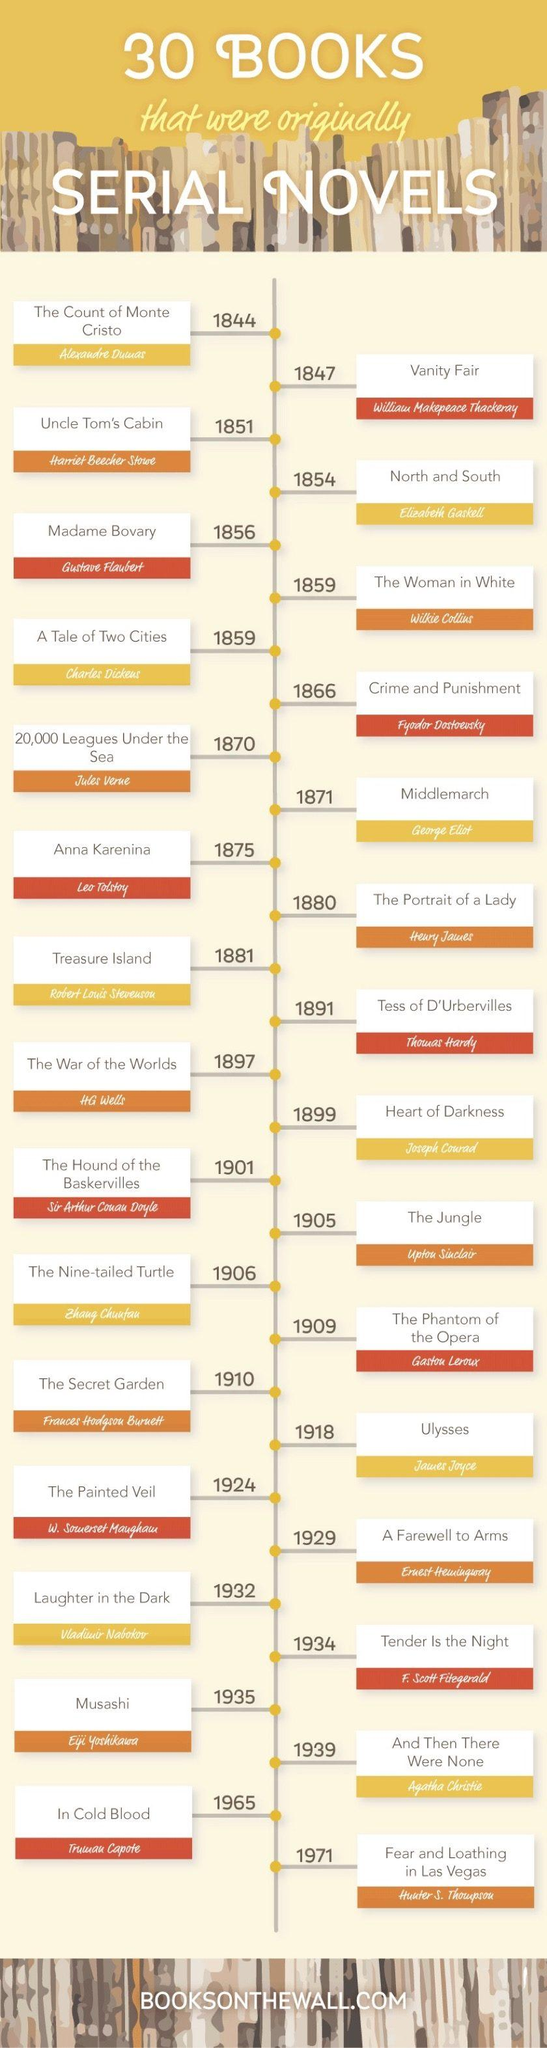Indicate a few pertinent items in this graphic. Truman Capote wrote the novel "In Cold Blood," which was published in 1965. The novel titled "Middle March" was published in 1871. Wilkie Collins is the author of 'The Woman in White'. Heart of Darkness" was first published in 1899. 